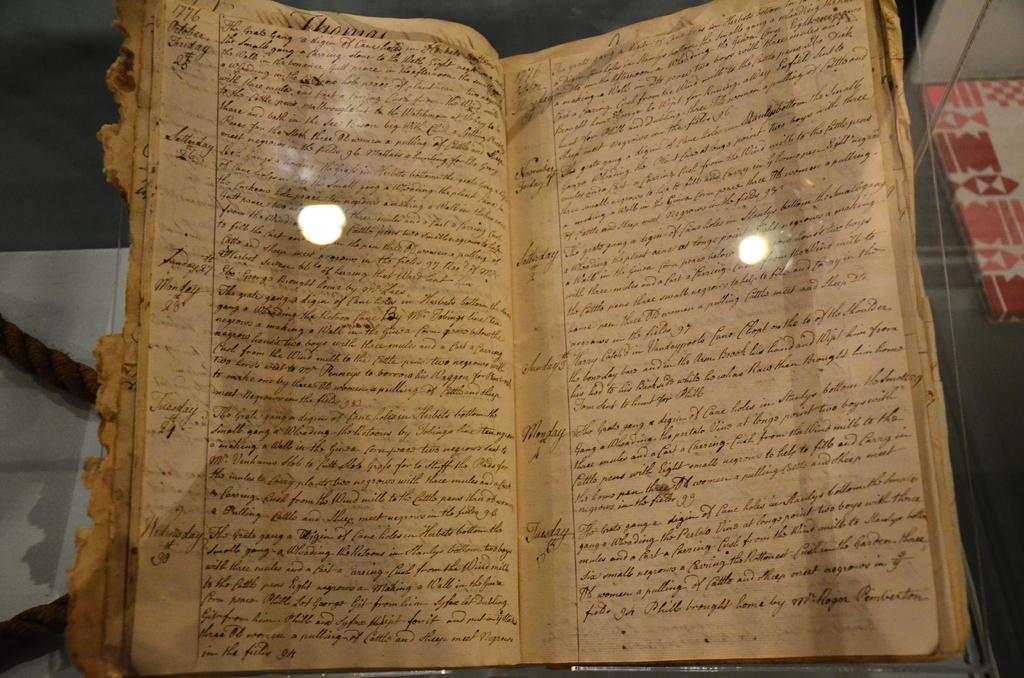<image>
Give a short and clear explanation of the subsequent image. A very old tatty book written in cursive; the word Thomas is visible. 